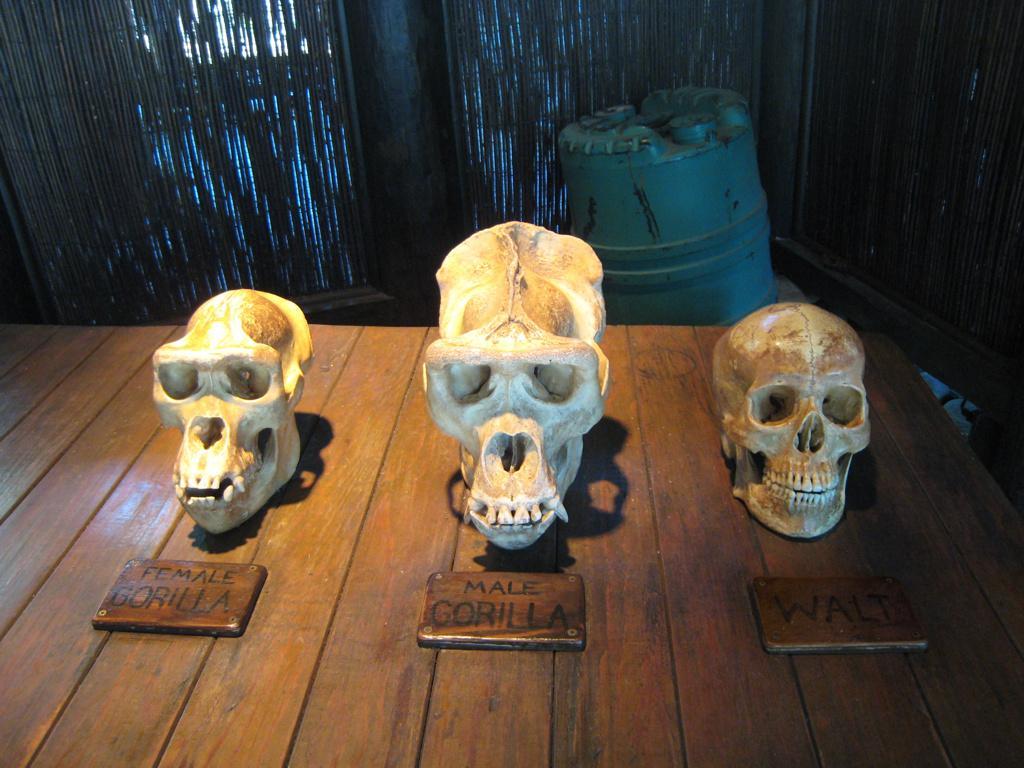Could you give a brief overview of what you see in this image? At the bottom of the image on the wooden surface there are three skulls. In front of them there are wooden name boards with names on it. Behind that wooden surface there is a blue color drum. Behind the drum there are curtains and pillars. 